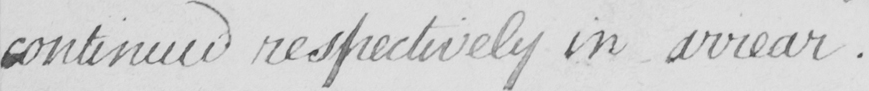Transcribe the text shown in this historical manuscript line. continued respectively in arrear . 